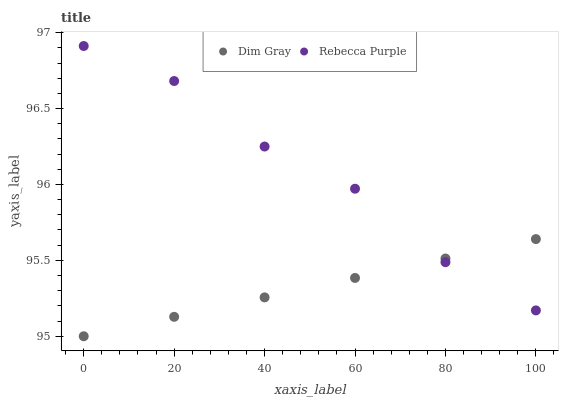Does Dim Gray have the minimum area under the curve?
Answer yes or no. Yes. Does Rebecca Purple have the maximum area under the curve?
Answer yes or no. Yes. Does Rebecca Purple have the minimum area under the curve?
Answer yes or no. No. Is Dim Gray the smoothest?
Answer yes or no. Yes. Is Rebecca Purple the roughest?
Answer yes or no. Yes. Is Rebecca Purple the smoothest?
Answer yes or no. No. Does Dim Gray have the lowest value?
Answer yes or no. Yes. Does Rebecca Purple have the lowest value?
Answer yes or no. No. Does Rebecca Purple have the highest value?
Answer yes or no. Yes. Does Rebecca Purple intersect Dim Gray?
Answer yes or no. Yes. Is Rebecca Purple less than Dim Gray?
Answer yes or no. No. Is Rebecca Purple greater than Dim Gray?
Answer yes or no. No. 